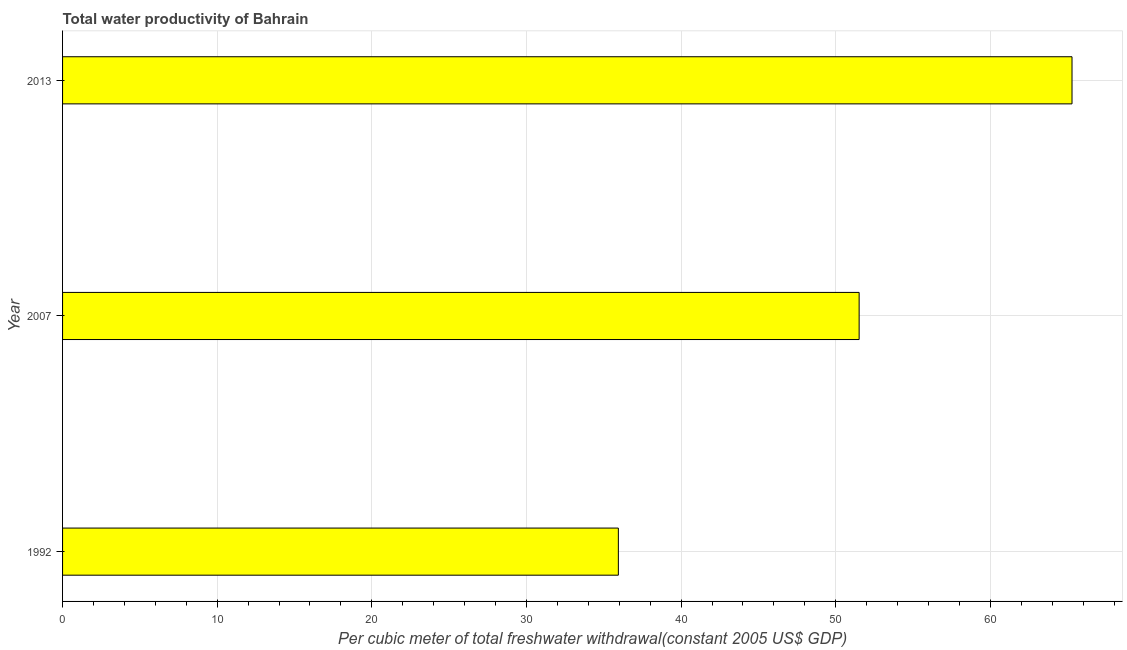Does the graph contain grids?
Ensure brevity in your answer.  Yes. What is the title of the graph?
Offer a very short reply. Total water productivity of Bahrain. What is the label or title of the X-axis?
Make the answer very short. Per cubic meter of total freshwater withdrawal(constant 2005 US$ GDP). What is the label or title of the Y-axis?
Give a very brief answer. Year. What is the total water productivity in 2013?
Provide a succinct answer. 65.28. Across all years, what is the maximum total water productivity?
Your answer should be compact. 65.28. Across all years, what is the minimum total water productivity?
Your answer should be compact. 35.94. In which year was the total water productivity maximum?
Provide a short and direct response. 2013. In which year was the total water productivity minimum?
Your response must be concise. 1992. What is the sum of the total water productivity?
Offer a terse response. 152.74. What is the difference between the total water productivity in 1992 and 2013?
Your answer should be very brief. -29.34. What is the average total water productivity per year?
Make the answer very short. 50.91. What is the median total water productivity?
Give a very brief answer. 51.52. Do a majority of the years between 1992 and 2013 (inclusive) have total water productivity greater than 36 US$?
Your response must be concise. Yes. What is the ratio of the total water productivity in 2007 to that in 2013?
Your answer should be compact. 0.79. Is the total water productivity in 1992 less than that in 2007?
Your response must be concise. Yes. Is the difference between the total water productivity in 2007 and 2013 greater than the difference between any two years?
Offer a very short reply. No. What is the difference between the highest and the second highest total water productivity?
Ensure brevity in your answer.  13.77. Is the sum of the total water productivity in 1992 and 2007 greater than the maximum total water productivity across all years?
Provide a succinct answer. Yes. What is the difference between the highest and the lowest total water productivity?
Provide a succinct answer. 29.34. In how many years, is the total water productivity greater than the average total water productivity taken over all years?
Keep it short and to the point. 2. How many bars are there?
Ensure brevity in your answer.  3. Are the values on the major ticks of X-axis written in scientific E-notation?
Offer a very short reply. No. What is the Per cubic meter of total freshwater withdrawal(constant 2005 US$ GDP) in 1992?
Make the answer very short. 35.94. What is the Per cubic meter of total freshwater withdrawal(constant 2005 US$ GDP) in 2007?
Your response must be concise. 51.52. What is the Per cubic meter of total freshwater withdrawal(constant 2005 US$ GDP) in 2013?
Provide a succinct answer. 65.28. What is the difference between the Per cubic meter of total freshwater withdrawal(constant 2005 US$ GDP) in 1992 and 2007?
Your answer should be compact. -15.57. What is the difference between the Per cubic meter of total freshwater withdrawal(constant 2005 US$ GDP) in 1992 and 2013?
Your answer should be compact. -29.34. What is the difference between the Per cubic meter of total freshwater withdrawal(constant 2005 US$ GDP) in 2007 and 2013?
Your response must be concise. -13.77. What is the ratio of the Per cubic meter of total freshwater withdrawal(constant 2005 US$ GDP) in 1992 to that in 2007?
Your answer should be compact. 0.7. What is the ratio of the Per cubic meter of total freshwater withdrawal(constant 2005 US$ GDP) in 1992 to that in 2013?
Your response must be concise. 0.55. What is the ratio of the Per cubic meter of total freshwater withdrawal(constant 2005 US$ GDP) in 2007 to that in 2013?
Give a very brief answer. 0.79. 